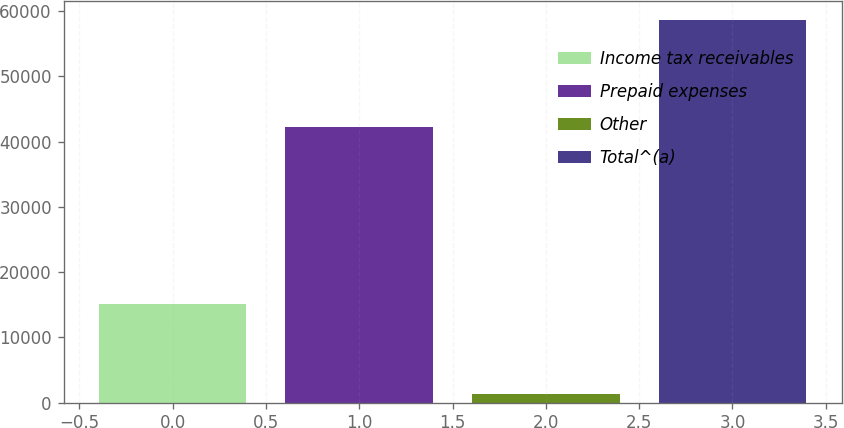Convert chart. <chart><loc_0><loc_0><loc_500><loc_500><bar_chart><fcel>Income tax receivables<fcel>Prepaid expenses<fcel>Other<fcel>Total^(a)<nl><fcel>15085<fcel>42240<fcel>1254<fcel>58579<nl></chart> 